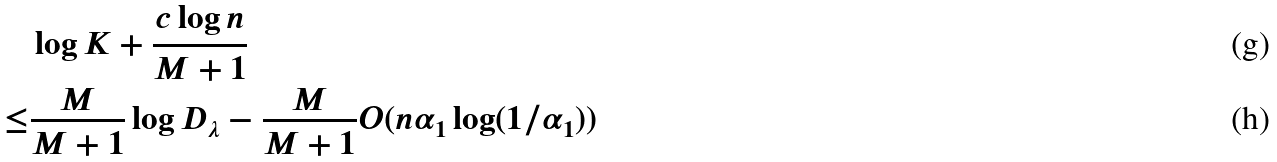Convert formula to latex. <formula><loc_0><loc_0><loc_500><loc_500>& \log K + \frac { c \log n } { M + 1 } \\ \leq & \frac { M } { M + 1 } \log D _ { \lambda } - \frac { M } { M + 1 } O ( n \alpha _ { 1 } \log ( 1 / \alpha _ { 1 } ) )</formula> 